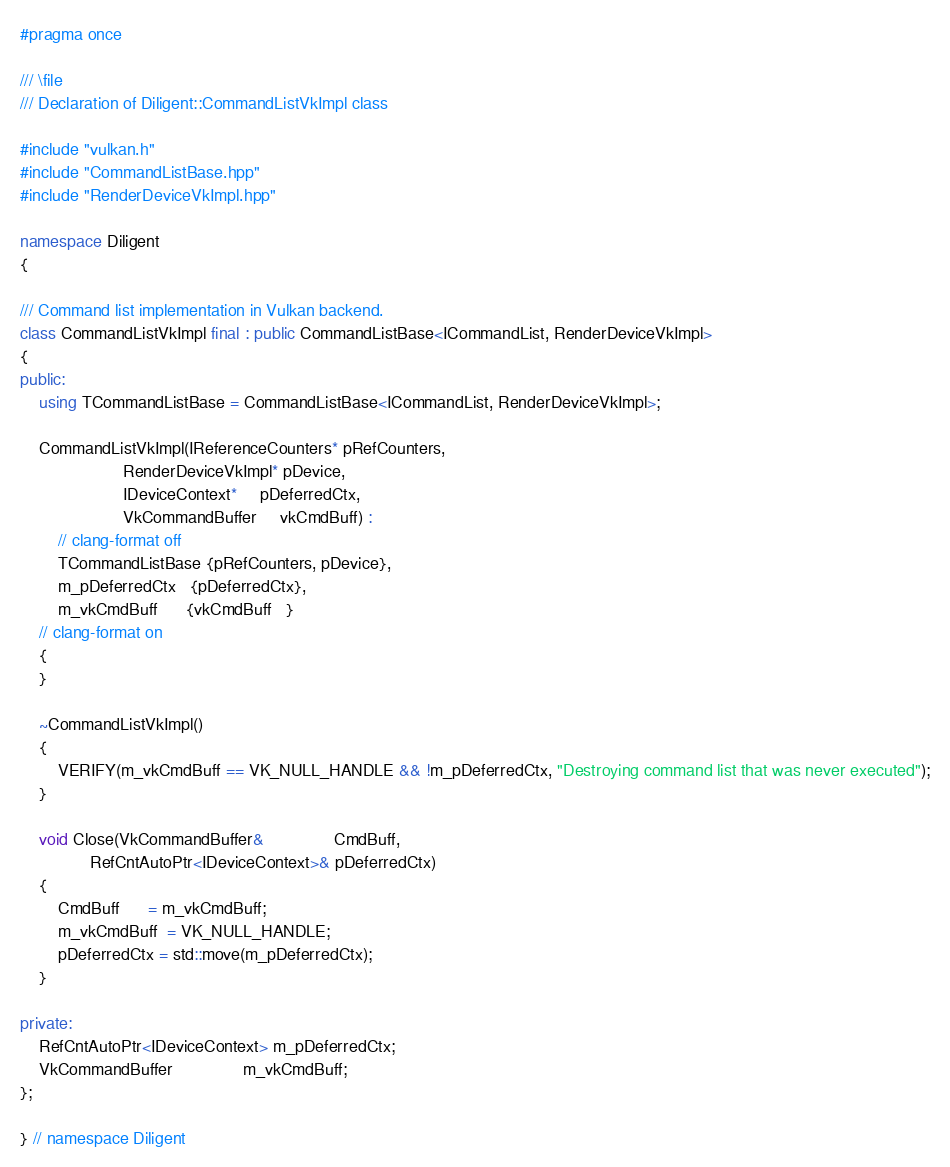Convert code to text. <code><loc_0><loc_0><loc_500><loc_500><_C++_>
#pragma once

/// \file
/// Declaration of Diligent::CommandListVkImpl class

#include "vulkan.h"
#include "CommandListBase.hpp"
#include "RenderDeviceVkImpl.hpp"

namespace Diligent
{

/// Command list implementation in Vulkan backend.
class CommandListVkImpl final : public CommandListBase<ICommandList, RenderDeviceVkImpl>
{
public:
    using TCommandListBase = CommandListBase<ICommandList, RenderDeviceVkImpl>;

    CommandListVkImpl(IReferenceCounters* pRefCounters,
                      RenderDeviceVkImpl* pDevice,
                      IDeviceContext*     pDeferredCtx,
                      VkCommandBuffer     vkCmdBuff) :
        // clang-format off
        TCommandListBase {pRefCounters, pDevice},
        m_pDeferredCtx   {pDeferredCtx},
        m_vkCmdBuff      {vkCmdBuff   }
    // clang-format on
    {
    }

    ~CommandListVkImpl()
    {
        VERIFY(m_vkCmdBuff == VK_NULL_HANDLE && !m_pDeferredCtx, "Destroying command list that was never executed");
    }

    void Close(VkCommandBuffer&               CmdBuff,
               RefCntAutoPtr<IDeviceContext>& pDeferredCtx)
    {
        CmdBuff      = m_vkCmdBuff;
        m_vkCmdBuff  = VK_NULL_HANDLE;
        pDeferredCtx = std::move(m_pDeferredCtx);
    }

private:
    RefCntAutoPtr<IDeviceContext> m_pDeferredCtx;
    VkCommandBuffer               m_vkCmdBuff;
};

} // namespace Diligent
</code> 